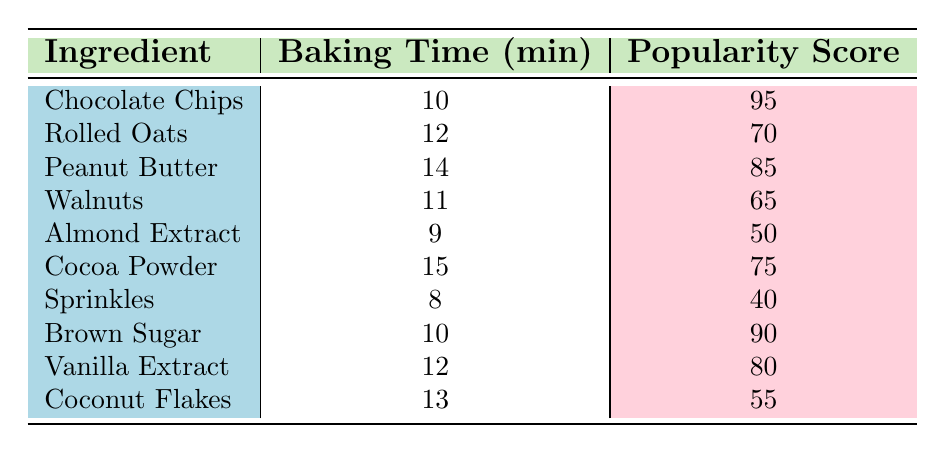What is the baking time for Chocolate Chips? Looking at the table, the row for Chocolate Chips shows the corresponding baking time is 10 minutes.
Answer: 10 minutes Which ingredient has the highest popularity score? The table lists the popularity scores for each ingredient, and Chocolate Chips has the highest score of 95.
Answer: Chocolate Chips What is the average baking time of all ingredients? To find the average baking time, sum the baking times (10 + 12 + 14 + 11 + 9 + 15 + 8 + 10 + 12 + 13 = 124) and divide by the number of ingredients (10). Thus, the average is 124/10 = 12.4 minutes.
Answer: 12.4 minutes Is the popularity score of Vanilla Extract greater than 70? According to the table, the popularity score of Vanilla Extract is 80, which is indeed greater than 70.
Answer: Yes What is the difference in popularity score between Sprinkles and Almond Extract? The popularity score of Sprinkles is 40, and for Almond Extract, it is 50. The difference is 50 - 40 = 10.
Answer: 10 How many ingredients have a baking time of 12 minutes or more? By examining the table, the ingredients that have a baking time of 12 minutes or more are Rolled Oats, Peanut Butter, Cocoa Powder, Coconut Flakes, and Vanilla Extract, totaling 5 ingredients.
Answer: 5 ingredients Which ingredient has a popularity score below 60? Looking at the popularity scores, both Walnuts (65) and Coconut Flakes (55) are below 60. Thus, Coconut Flakes is the ingredient that meets this condition as it has a score of 55.
Answer: Coconut Flakes What is the total popularity score of ingredients with a baking time of 10 minutes or less? The ingredients with 10 minutes or less are Chocolate Chips (95), Brown Sugar (90), and Sprinkles (40). Their total popularity score is 95 + 90 + 40 = 225.
Answer: 225 Is there an ingredient with both a baking time of 14 minutes and a popularity score above 80? The only ingredient with a baking time of 14 minutes is Peanut Butter, which has a popularity score of 85, so this statement is true.
Answer: Yes 